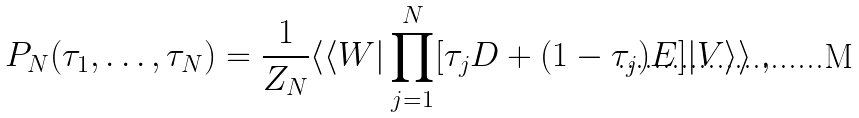<formula> <loc_0><loc_0><loc_500><loc_500>P _ { N } ( \tau _ { 1 } , \dots , \tau _ { N } ) = \frac { 1 } { Z _ { N } } \langle \langle W | \prod _ { j = 1 } ^ { N } [ \tau _ { j } D + ( 1 - \tau _ { j } ) E ] | V \rangle \rangle \ ,</formula> 